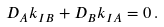Convert formula to latex. <formula><loc_0><loc_0><loc_500><loc_500>D _ { A } k _ { I B } + D _ { B } k _ { I A } = 0 \, .</formula> 